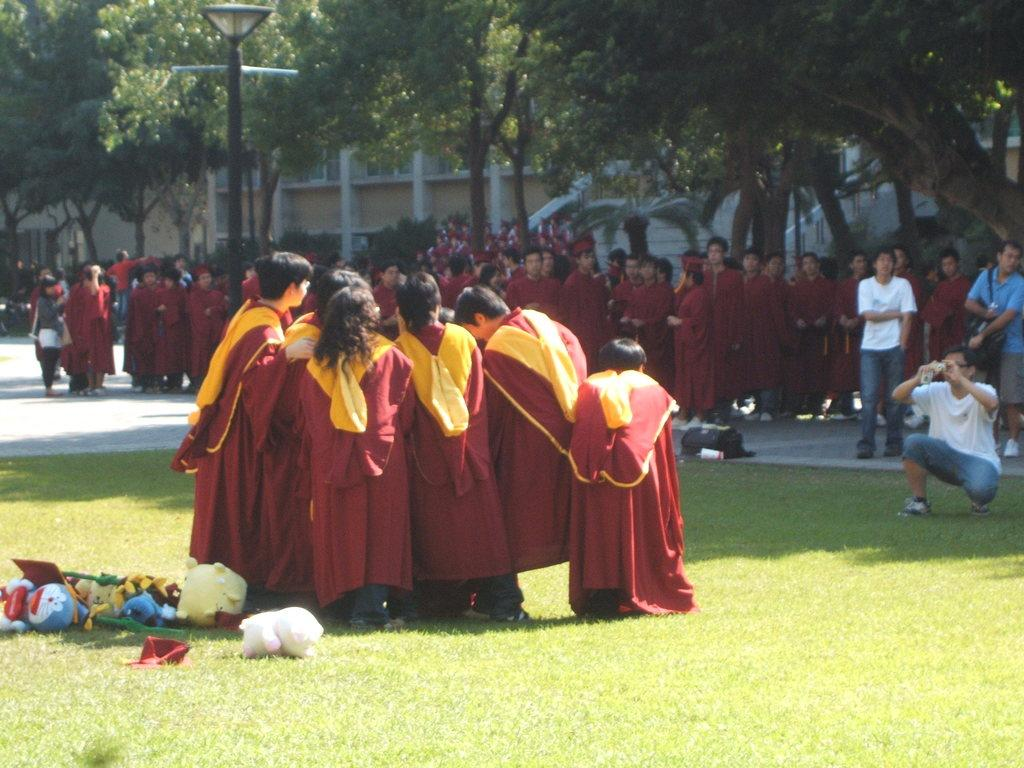How many people are present in the image? There are many people in the image. What is on the ground in the image? There is grass on the ground. What objects can be seen in the image besides people? There are toys in the image. What can be seen in the background of the image? There are trees and a wall in the background. What is the tall, vertical structure in the image? There is a light pole in the image. What type of steel is used to construct the basketball hoop in the image? There is no basketball hoop present in the image, so it is not possible to determine the type of steel used in its construction. 